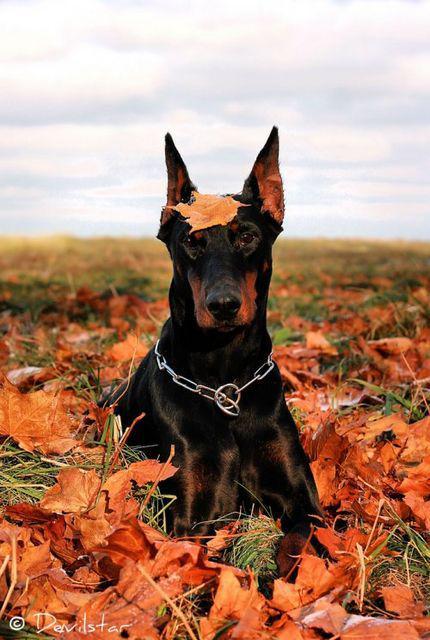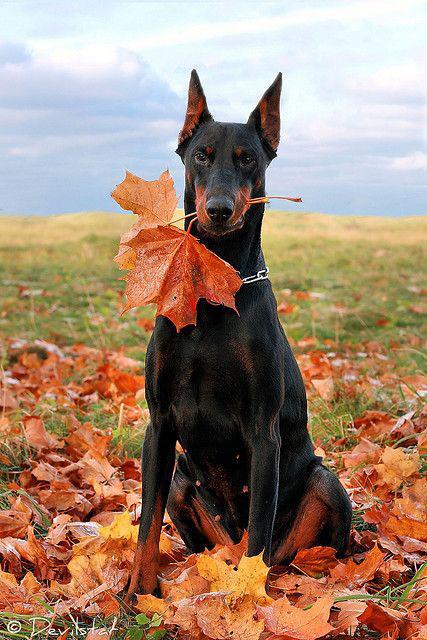The first image is the image on the left, the second image is the image on the right. For the images displayed, is the sentence "At least one image features a doberman sitting upright in autumn foliage, and all dobermans are in some pose on autumn foilage." factually correct? Answer yes or no. Yes. The first image is the image on the left, the second image is the image on the right. Evaluate the accuracy of this statement regarding the images: "The dogs are all sitting in leaves.". Is it true? Answer yes or no. Yes. 